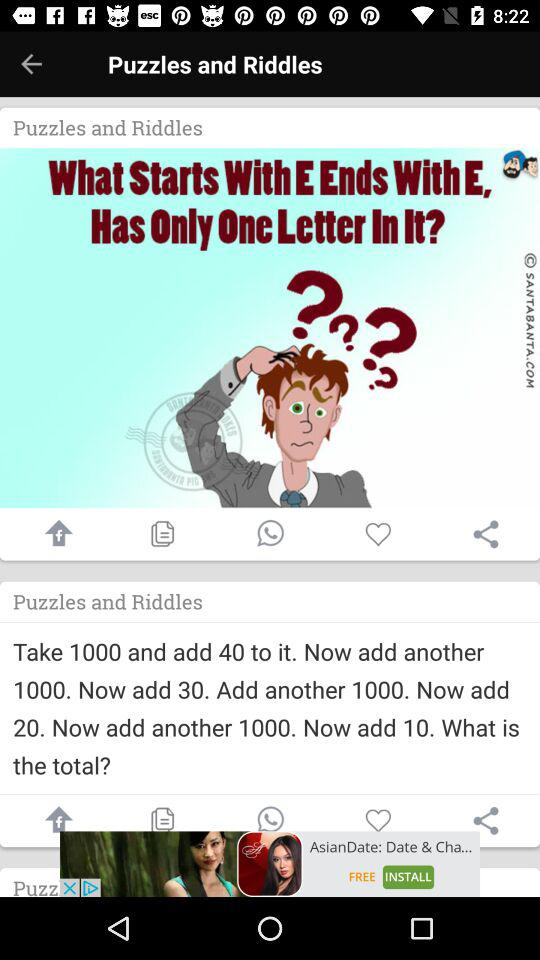What are the puzzles and riddles? The puzzles and riddles are "What Starts With E Ends With E, Has Only One Letter In It?" and "Take 1000 and add 40 to it. Now add another 1000. Now add 30. Add another 1000. Now add 20. Now add another 1000. Now add 10. What is the total?". 